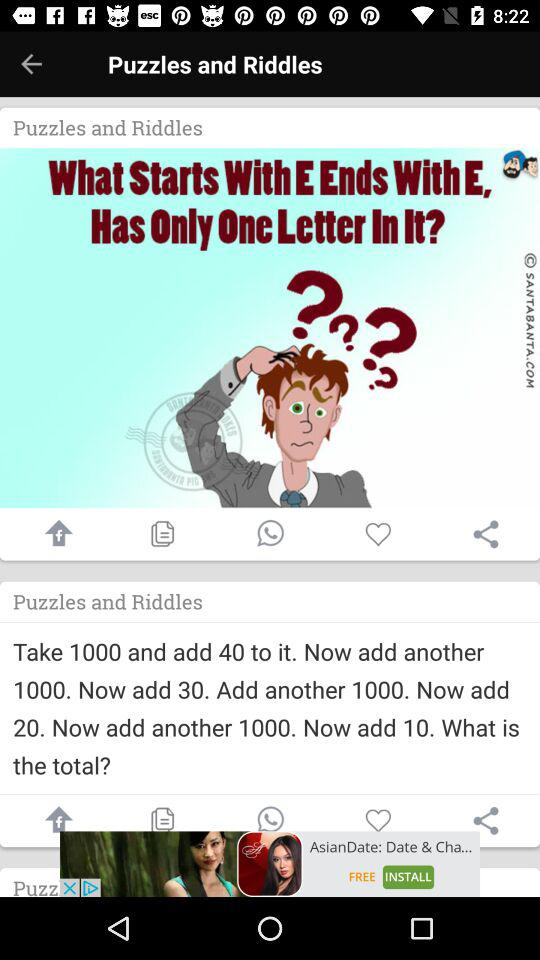What are the puzzles and riddles? The puzzles and riddles are "What Starts With E Ends With E, Has Only One Letter In It?" and "Take 1000 and add 40 to it. Now add another 1000. Now add 30. Add another 1000. Now add 20. Now add another 1000. Now add 10. What is the total?". 